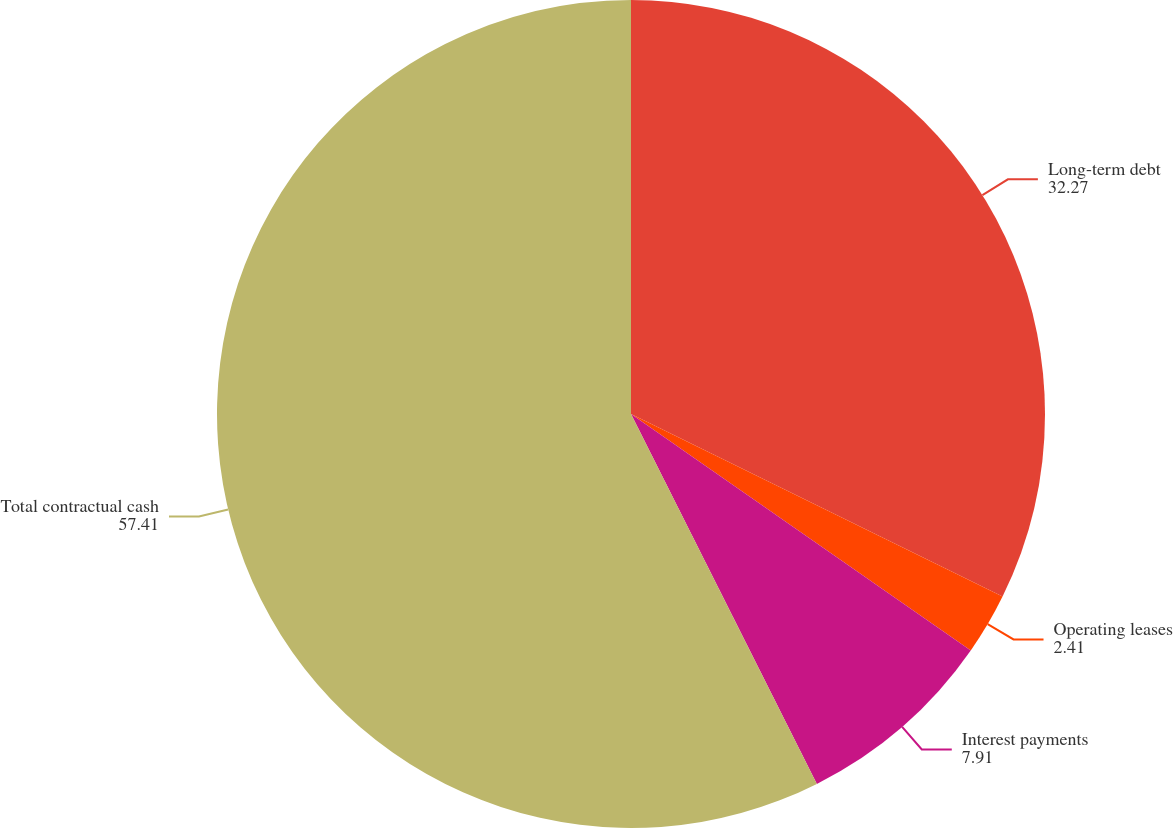Convert chart to OTSL. <chart><loc_0><loc_0><loc_500><loc_500><pie_chart><fcel>Long-term debt<fcel>Operating leases<fcel>Interest payments<fcel>Total contractual cash<nl><fcel>32.27%<fcel>2.41%<fcel>7.91%<fcel>57.41%<nl></chart> 